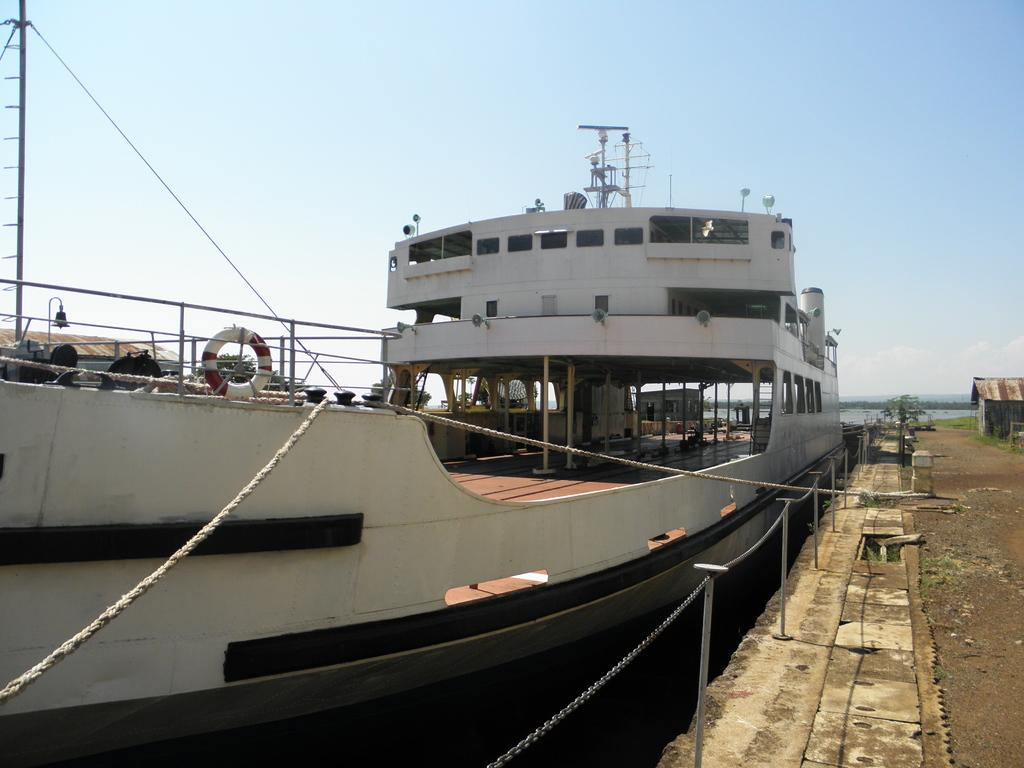What is the main subject of the image? The main subject of the image is a ship. What are the ropes used for in the image? The ropes are not explicitly described in the facts, but they are likely used for tying or securing the ship. What type of vegetation is visible in the image? There is grass visible in the image. What is visible in the background of the image? The sky is visible in the background of the image. How many stitches are visible on the ship's sail in the image? There is no mention of stitches or a sail on the ship in the provided facts, so it cannot be determined from the image. What type of toothbrush is the ship using to clean its hull in the image? There is no toothbrush present in the image, and ships do not use toothbrushes to clean their hulls. 